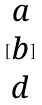Convert formula to latex. <formula><loc_0><loc_0><loc_500><loc_500>[ \begin{matrix} a \\ b \\ d \end{matrix} ]</formula> 